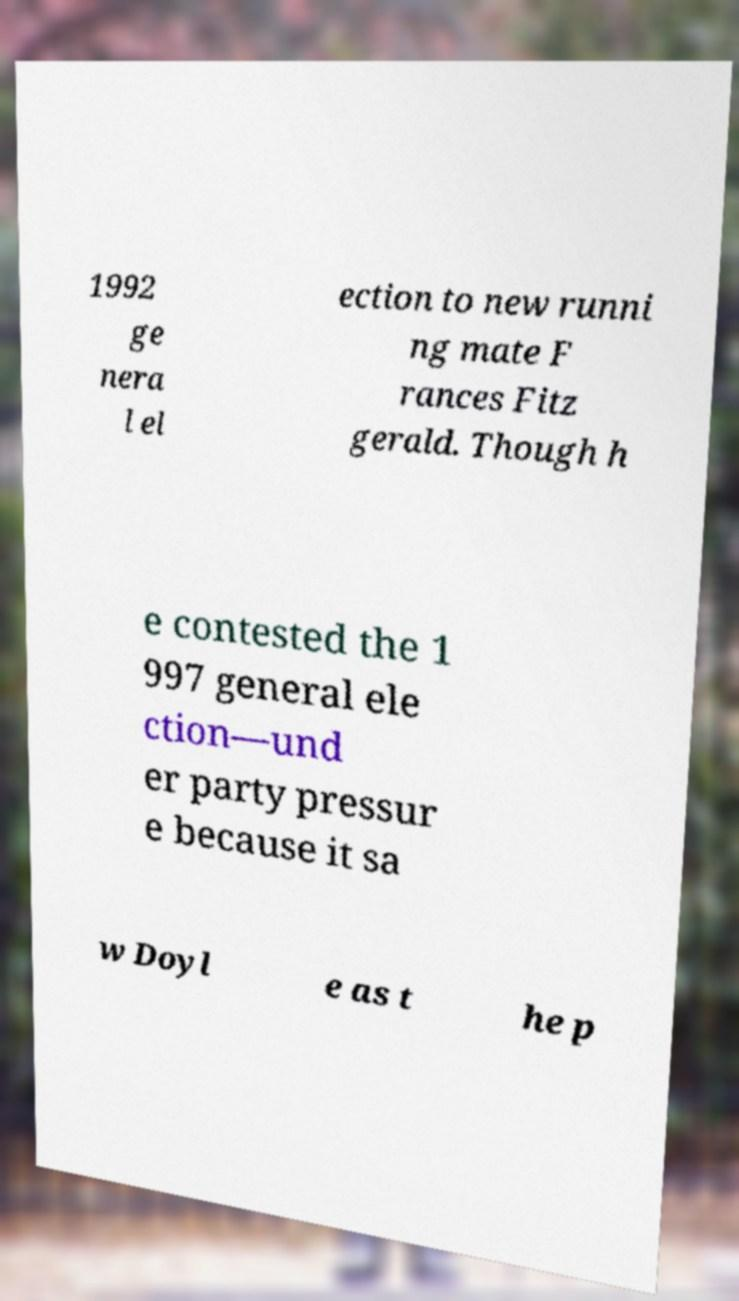Could you assist in decoding the text presented in this image and type it out clearly? 1992 ge nera l el ection to new runni ng mate F rances Fitz gerald. Though h e contested the 1 997 general ele ction—und er party pressur e because it sa w Doyl e as t he p 